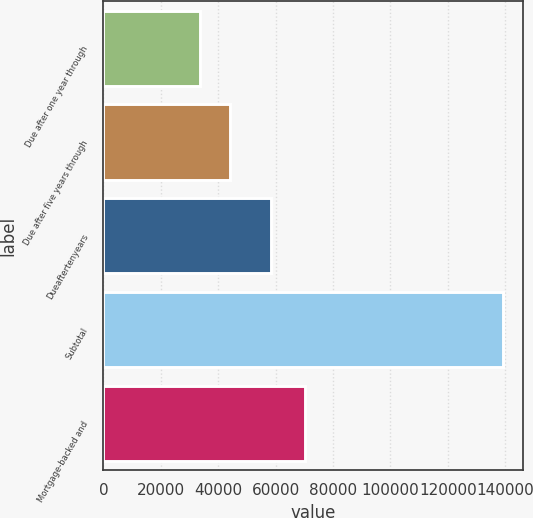Convert chart to OTSL. <chart><loc_0><loc_0><loc_500><loc_500><bar_chart><fcel>Due after one year through<fcel>Due after five years through<fcel>Dueaftertenyears<fcel>Subtotal<fcel>Mortgage-backed and<nl><fcel>33604<fcel>44162.4<fcel>58547<fcel>139188<fcel>70320<nl></chart> 